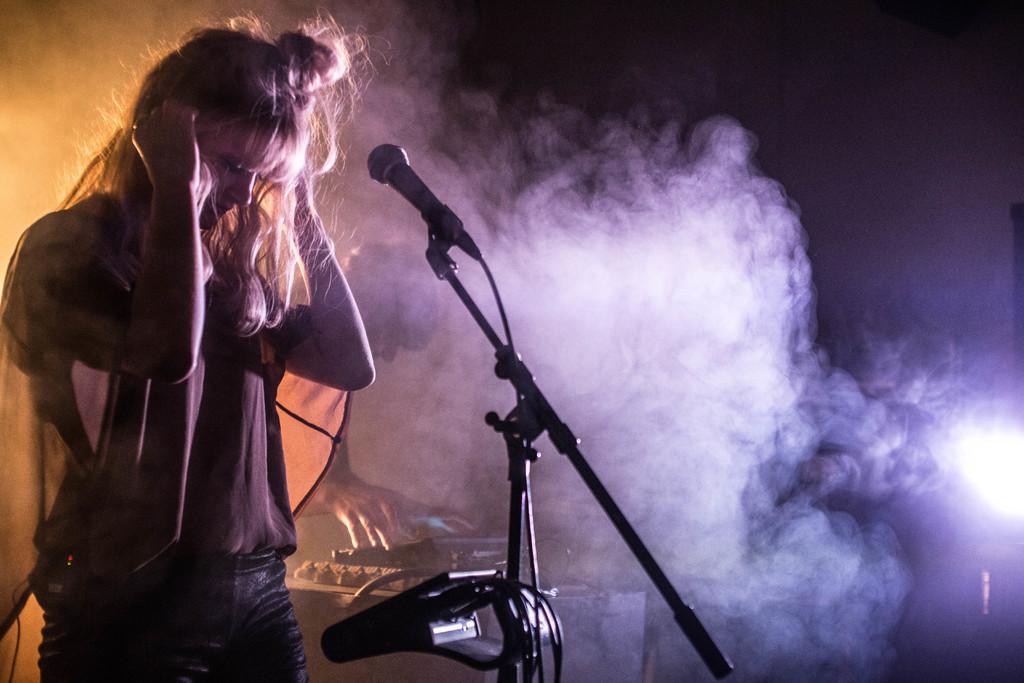How would you summarize this image in a sentence or two? In this image, we can see a woman is standing in-front of a microphone. Here we can see wires, stand and some object. Behind her, we can see a person is doing something with the black color object. Here there is a smoke and light. Background there is a dark view. 